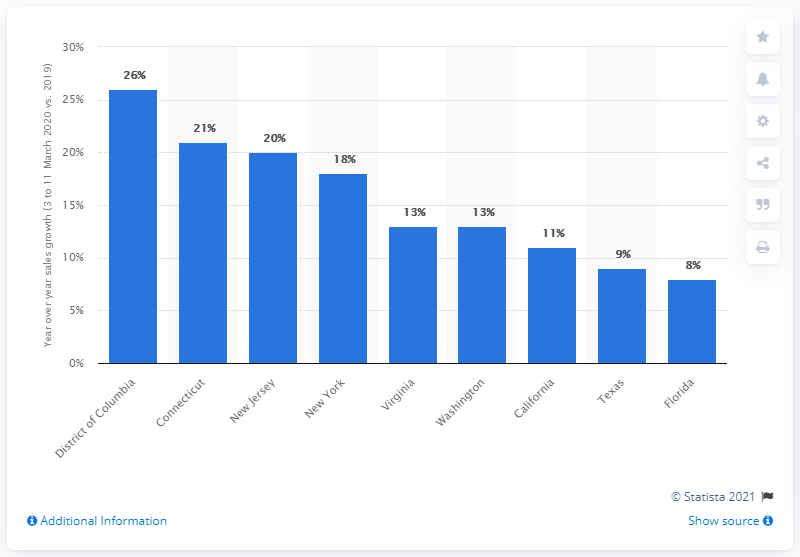Identify some key points in this picture. On March 26, 2020, the city with the highest number of confirmed cases of coronavirus in the United States was New York. During the week of March 5-11, 2020, the sales of general merchandise, grocers, and Amazon & Paypal grew by 26%. 